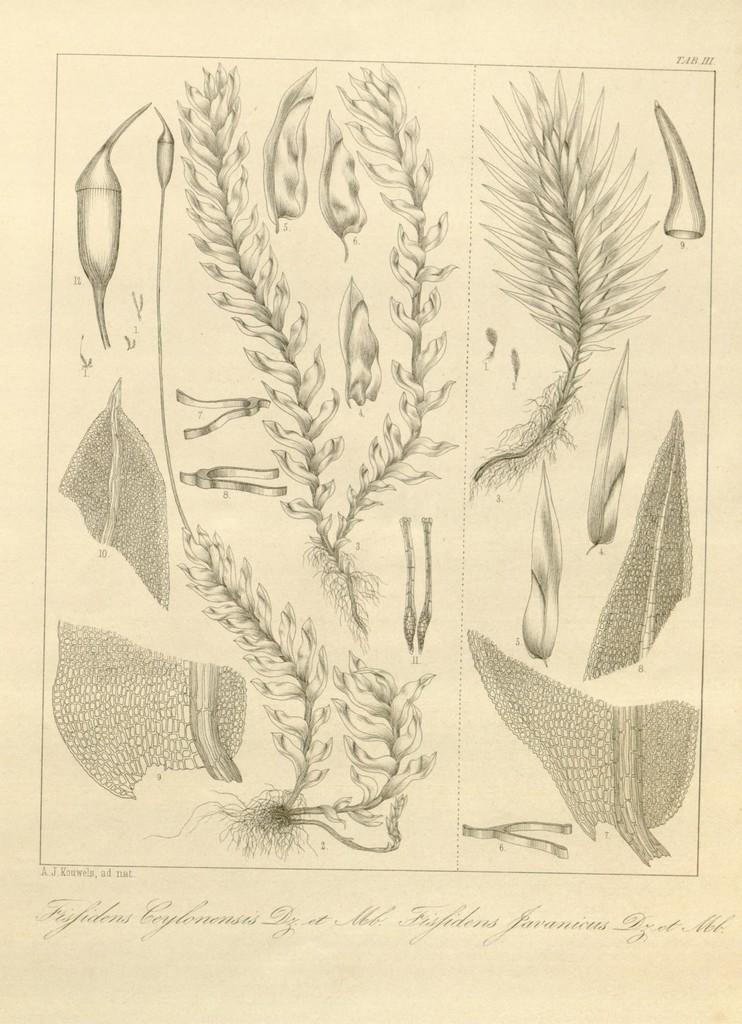What is the main object in the image? The image contains a paper. What can be found on the paper? There are pictures on the paper. What do the pictures depict? The pictures depict plants and trees. Is there any text on the paper? Yes, there is text at the bottom of the paper. Can you tell me how much milk is being poured into the paper in the image? There is no milk being poured into the paper in the image; it contains pictures of plants and trees and text at the bottom. 